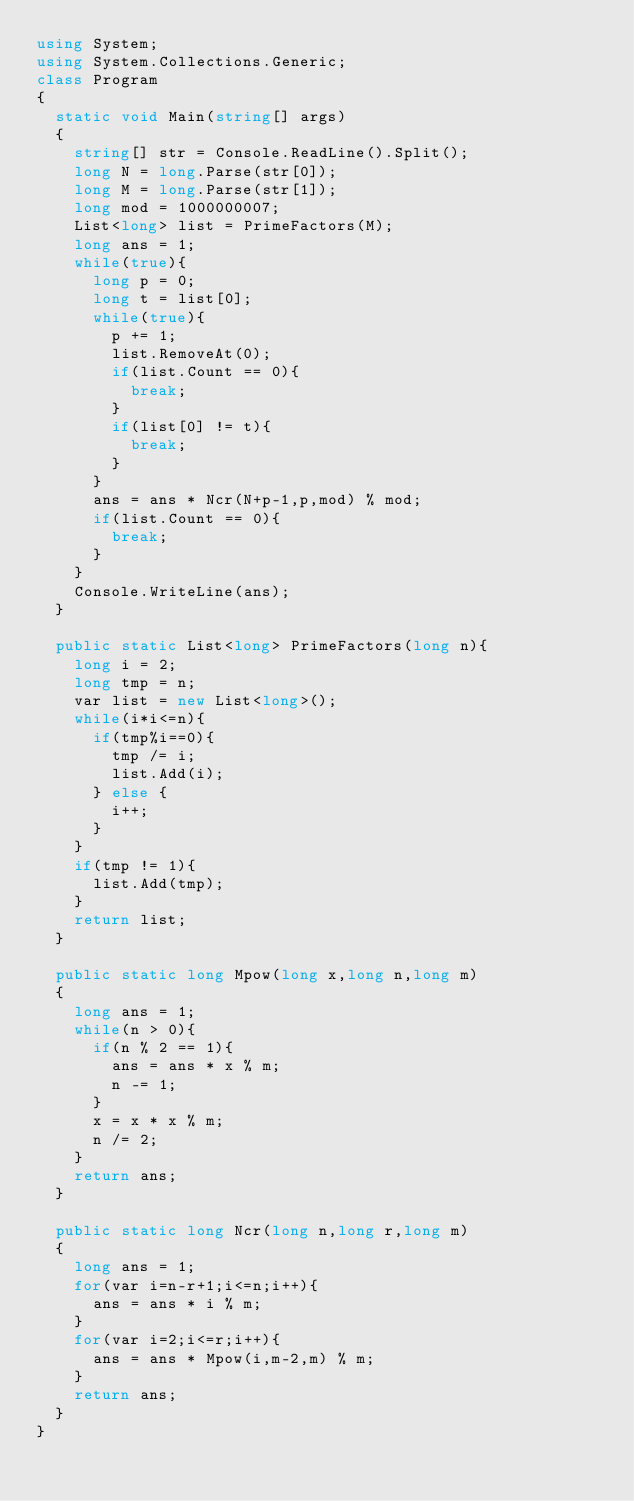<code> <loc_0><loc_0><loc_500><loc_500><_C#_>using System;
using System.Collections.Generic;
class Program
{
	static void Main(string[] args)
	{
		string[] str = Console.ReadLine().Split();
		long N = long.Parse(str[0]);
		long M = long.Parse(str[1]);
		long mod = 1000000007;
		List<long> list = PrimeFactors(M);
		long ans = 1;
		while(true){
			long p = 0;
			long t = list[0];
			while(true){
				p += 1;
				list.RemoveAt(0);
				if(list.Count == 0){
					break;
				}
				if(list[0] != t){
					break;
				}
			}
			ans = ans * Ncr(N+p-1,p,mod) % mod;
			if(list.Count == 0){
				break;
			}
		}
		Console.WriteLine(ans);
	}

	public static List<long> PrimeFactors(long n){
		long i = 2;
		long tmp = n;
		var list = new List<long>();
		while(i*i<=n){
			if(tmp%i==0){
				tmp /= i;
				list.Add(i);
			} else {
				i++;
			}
		}
		if(tmp != 1){
			list.Add(tmp);
		}
		return list;
	}

	public static long Mpow(long x,long n,long m)
	{
		long ans = 1;
		while(n > 0){
			if(n % 2 == 1){
				ans = ans * x % m;
				n -= 1;
			}
			x = x * x % m;
			n /= 2;
		}
		return ans;
	}

	public static long Ncr(long n,long r,long m)
	{
		long ans = 1;
		for(var i=n-r+1;i<=n;i++){
			ans = ans * i % m;
		}
		for(var i=2;i<=r;i++){
			ans = ans * Mpow(i,m-2,m) % m;
		}
		return ans;
	}
}</code> 